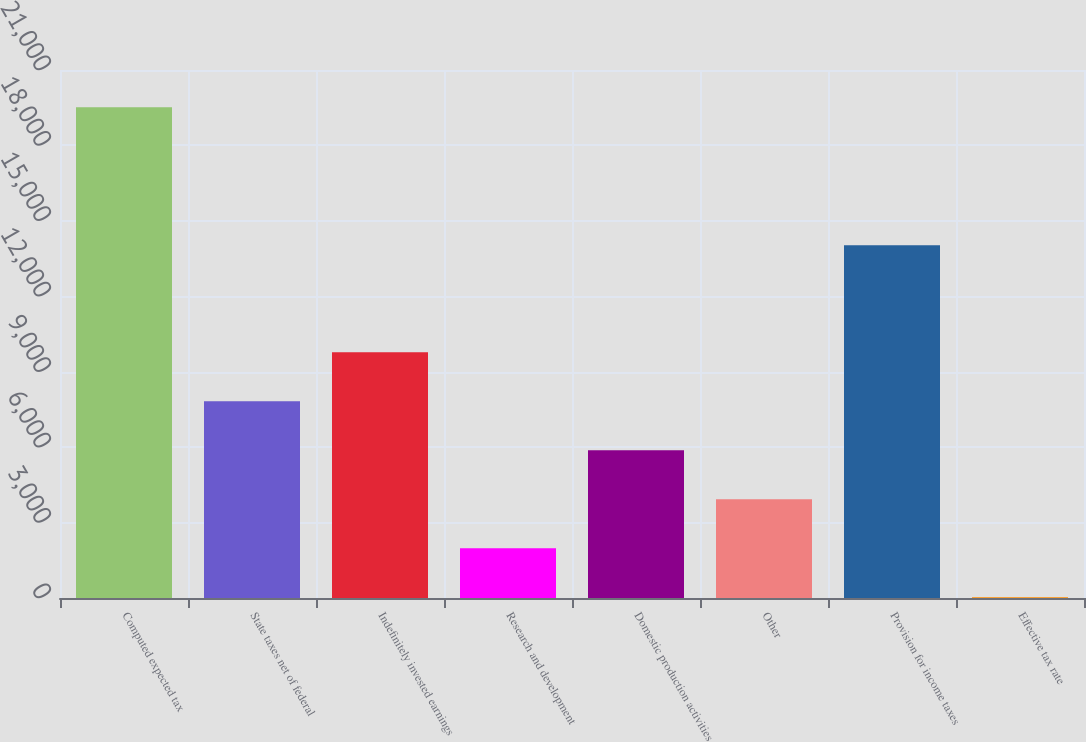Convert chart. <chart><loc_0><loc_0><loc_500><loc_500><bar_chart><fcel>Computed expected tax<fcel>State taxes net of federal<fcel>Indefinitely invested earnings<fcel>Research and development<fcel>Domestic production activities<fcel>Other<fcel>Provision for income taxes<fcel>Effective tax rate<nl><fcel>19517<fcel>7821.92<fcel>9771.1<fcel>1974.38<fcel>5872.74<fcel>3923.56<fcel>14030<fcel>25.2<nl></chart> 